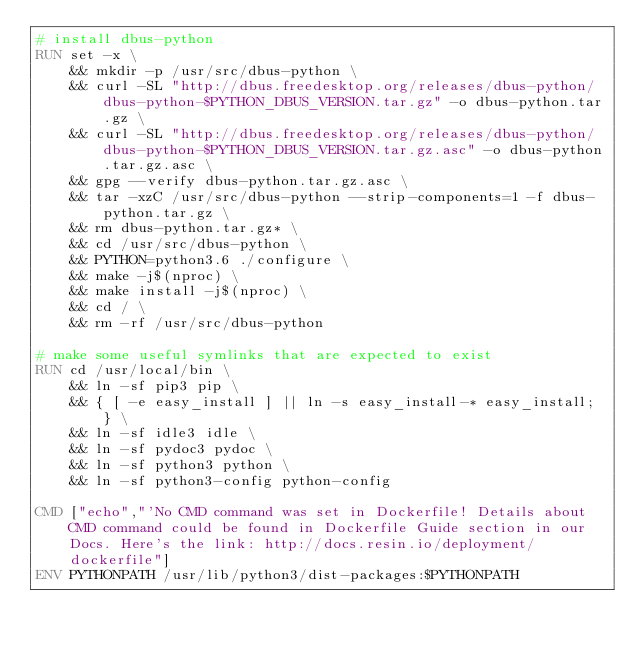Convert code to text. <code><loc_0><loc_0><loc_500><loc_500><_Dockerfile_># install dbus-python
RUN set -x \
	&& mkdir -p /usr/src/dbus-python \
	&& curl -SL "http://dbus.freedesktop.org/releases/dbus-python/dbus-python-$PYTHON_DBUS_VERSION.tar.gz" -o dbus-python.tar.gz \
	&& curl -SL "http://dbus.freedesktop.org/releases/dbus-python/dbus-python-$PYTHON_DBUS_VERSION.tar.gz.asc" -o dbus-python.tar.gz.asc \
	&& gpg --verify dbus-python.tar.gz.asc \
	&& tar -xzC /usr/src/dbus-python --strip-components=1 -f dbus-python.tar.gz \
	&& rm dbus-python.tar.gz* \
	&& cd /usr/src/dbus-python \
	&& PYTHON=python3.6 ./configure \
	&& make -j$(nproc) \
	&& make install -j$(nproc) \
	&& cd / \
	&& rm -rf /usr/src/dbus-python

# make some useful symlinks that are expected to exist
RUN cd /usr/local/bin \
	&& ln -sf pip3 pip \
	&& { [ -e easy_install ] || ln -s easy_install-* easy_install; } \
	&& ln -sf idle3 idle \
	&& ln -sf pydoc3 pydoc \
	&& ln -sf python3 python \
	&& ln -sf python3-config python-config

CMD ["echo","'No CMD command was set in Dockerfile! Details about CMD command could be found in Dockerfile Guide section in our Docs. Here's the link: http://docs.resin.io/deployment/dockerfile"]
ENV PYTHONPATH /usr/lib/python3/dist-packages:$PYTHONPATH
</code> 